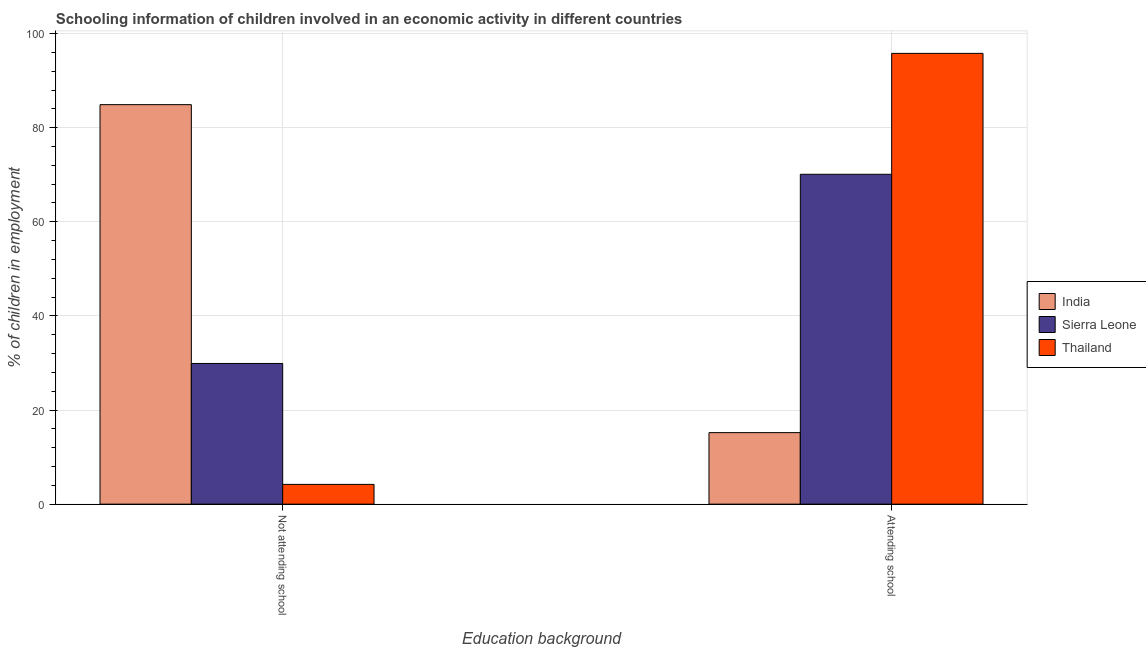How many groups of bars are there?
Offer a very short reply. 2. How many bars are there on the 2nd tick from the left?
Ensure brevity in your answer.  3. How many bars are there on the 1st tick from the right?
Provide a succinct answer. 3. What is the label of the 2nd group of bars from the left?
Provide a succinct answer. Attending school. Across all countries, what is the maximum percentage of employed children who are not attending school?
Provide a succinct answer. 84.9. In which country was the percentage of employed children who are not attending school maximum?
Give a very brief answer. India. In which country was the percentage of employed children who are not attending school minimum?
Ensure brevity in your answer.  Thailand. What is the total percentage of employed children who are not attending school in the graph?
Offer a very short reply. 119. What is the difference between the percentage of employed children who are attending school in Thailand and that in Sierra Leone?
Ensure brevity in your answer.  25.7. What is the difference between the percentage of employed children who are attending school in India and the percentage of employed children who are not attending school in Sierra Leone?
Provide a short and direct response. -14.7. What is the average percentage of employed children who are attending school per country?
Give a very brief answer. 60.37. What is the difference between the percentage of employed children who are attending school and percentage of employed children who are not attending school in Sierra Leone?
Your answer should be compact. 40.2. What is the ratio of the percentage of employed children who are not attending school in Thailand to that in India?
Keep it short and to the point. 0.05. Is the percentage of employed children who are attending school in Sierra Leone less than that in Thailand?
Your answer should be compact. Yes. In how many countries, is the percentage of employed children who are not attending school greater than the average percentage of employed children who are not attending school taken over all countries?
Your response must be concise. 1. What does the 2nd bar from the left in Attending school represents?
Offer a very short reply. Sierra Leone. Are all the bars in the graph horizontal?
Offer a very short reply. No. What is the difference between two consecutive major ticks on the Y-axis?
Ensure brevity in your answer.  20. Does the graph contain grids?
Your response must be concise. Yes. What is the title of the graph?
Keep it short and to the point. Schooling information of children involved in an economic activity in different countries. Does "Small states" appear as one of the legend labels in the graph?
Offer a very short reply. No. What is the label or title of the X-axis?
Your answer should be compact. Education background. What is the label or title of the Y-axis?
Make the answer very short. % of children in employment. What is the % of children in employment of India in Not attending school?
Keep it short and to the point. 84.9. What is the % of children in employment of Sierra Leone in Not attending school?
Keep it short and to the point. 29.9. What is the % of children in employment in India in Attending school?
Provide a short and direct response. 15.2. What is the % of children in employment of Sierra Leone in Attending school?
Provide a short and direct response. 70.1. What is the % of children in employment of Thailand in Attending school?
Offer a terse response. 95.8. Across all Education background, what is the maximum % of children in employment in India?
Keep it short and to the point. 84.9. Across all Education background, what is the maximum % of children in employment of Sierra Leone?
Provide a succinct answer. 70.1. Across all Education background, what is the maximum % of children in employment in Thailand?
Your response must be concise. 95.8. Across all Education background, what is the minimum % of children in employment in India?
Keep it short and to the point. 15.2. Across all Education background, what is the minimum % of children in employment of Sierra Leone?
Ensure brevity in your answer.  29.9. What is the total % of children in employment in India in the graph?
Offer a very short reply. 100.1. What is the difference between the % of children in employment in India in Not attending school and that in Attending school?
Make the answer very short. 69.7. What is the difference between the % of children in employment of Sierra Leone in Not attending school and that in Attending school?
Give a very brief answer. -40.2. What is the difference between the % of children in employment in Thailand in Not attending school and that in Attending school?
Offer a very short reply. -91.6. What is the difference between the % of children in employment in India in Not attending school and the % of children in employment in Sierra Leone in Attending school?
Your answer should be compact. 14.8. What is the difference between the % of children in employment of Sierra Leone in Not attending school and the % of children in employment of Thailand in Attending school?
Your answer should be compact. -65.9. What is the average % of children in employment in India per Education background?
Keep it short and to the point. 50.05. What is the average % of children in employment in Sierra Leone per Education background?
Make the answer very short. 50. What is the difference between the % of children in employment of India and % of children in employment of Thailand in Not attending school?
Give a very brief answer. 80.7. What is the difference between the % of children in employment in Sierra Leone and % of children in employment in Thailand in Not attending school?
Your answer should be compact. 25.7. What is the difference between the % of children in employment in India and % of children in employment in Sierra Leone in Attending school?
Keep it short and to the point. -54.9. What is the difference between the % of children in employment of India and % of children in employment of Thailand in Attending school?
Make the answer very short. -80.6. What is the difference between the % of children in employment in Sierra Leone and % of children in employment in Thailand in Attending school?
Your response must be concise. -25.7. What is the ratio of the % of children in employment in India in Not attending school to that in Attending school?
Make the answer very short. 5.59. What is the ratio of the % of children in employment in Sierra Leone in Not attending school to that in Attending school?
Make the answer very short. 0.43. What is the ratio of the % of children in employment in Thailand in Not attending school to that in Attending school?
Offer a terse response. 0.04. What is the difference between the highest and the second highest % of children in employment of India?
Keep it short and to the point. 69.7. What is the difference between the highest and the second highest % of children in employment in Sierra Leone?
Ensure brevity in your answer.  40.2. What is the difference between the highest and the second highest % of children in employment of Thailand?
Your response must be concise. 91.6. What is the difference between the highest and the lowest % of children in employment of India?
Your answer should be compact. 69.7. What is the difference between the highest and the lowest % of children in employment of Sierra Leone?
Provide a succinct answer. 40.2. What is the difference between the highest and the lowest % of children in employment in Thailand?
Give a very brief answer. 91.6. 